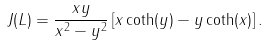<formula> <loc_0><loc_0><loc_500><loc_500>J ( L ) = \frac { x y } { x ^ { 2 } - y ^ { 2 } } \left [ x \coth ( y ) - y \coth ( x ) \right ] .</formula> 